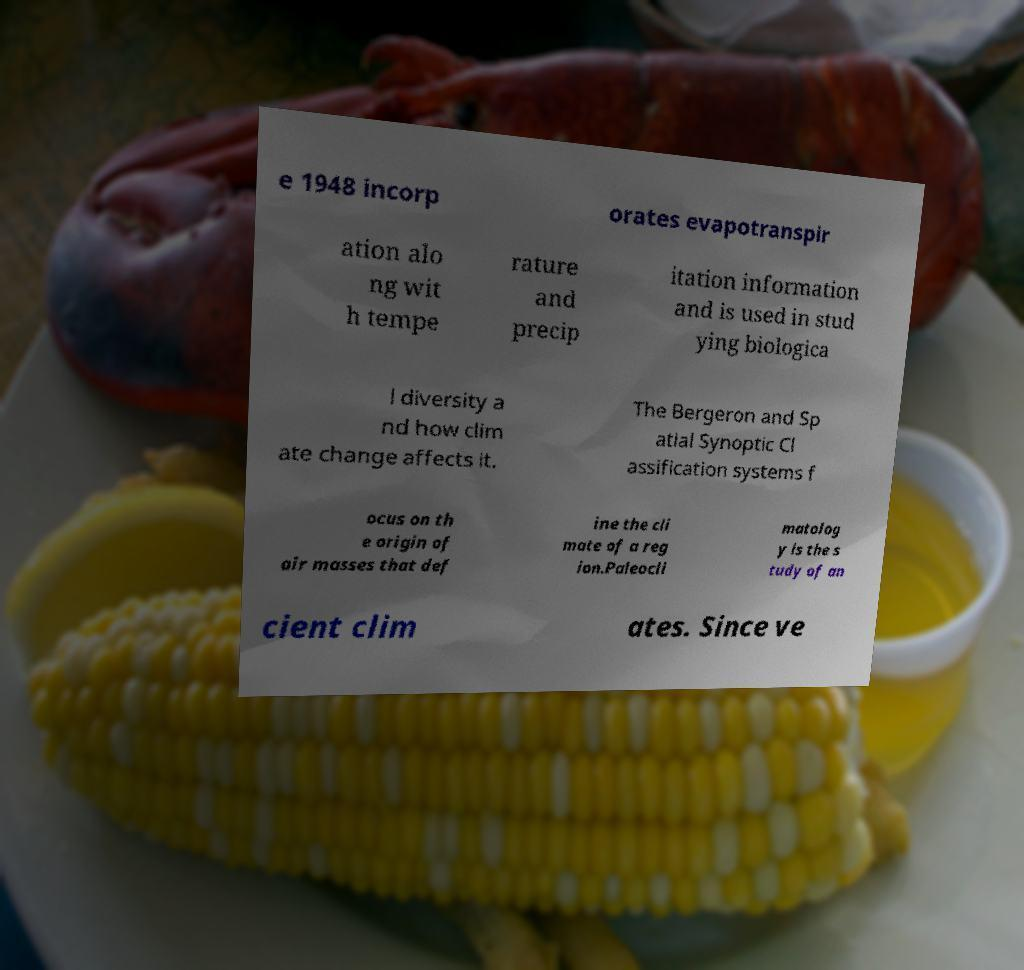There's text embedded in this image that I need extracted. Can you transcribe it verbatim? e 1948 incorp orates evapotranspir ation alo ng wit h tempe rature and precip itation information and is used in stud ying biologica l diversity a nd how clim ate change affects it. The Bergeron and Sp atial Synoptic Cl assification systems f ocus on th e origin of air masses that def ine the cli mate of a reg ion.Paleocli matolog y is the s tudy of an cient clim ates. Since ve 